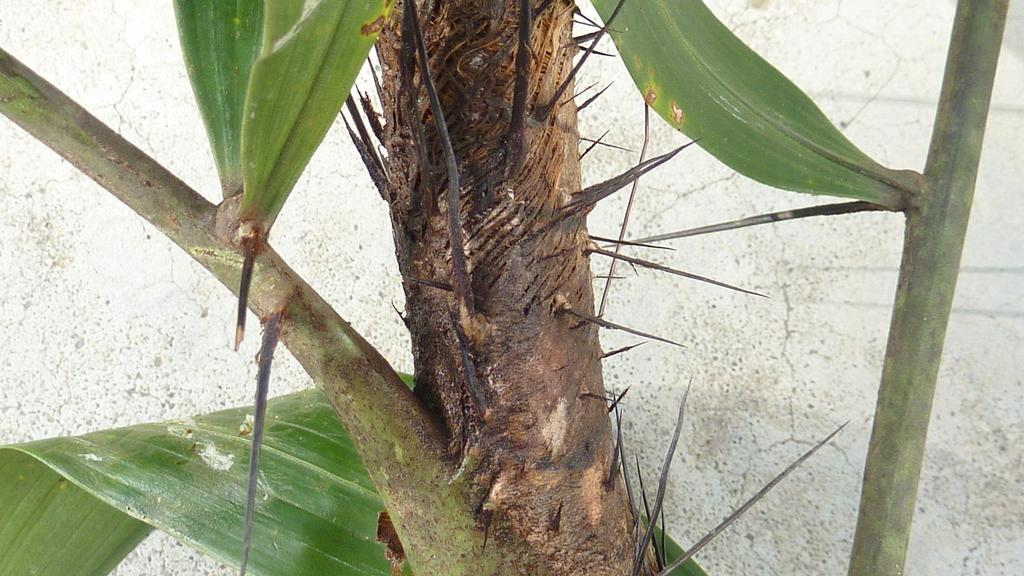What type of object is present in the image? There is a plant in the image. Can you describe the appearance of the plant? The plant has sharp, pointed edges. Does the plant have any other features? Yes, the plant has leaves. How many kittens are playing on the plant in the image? There are no kittens present in the image; it only features a plant with sharp, pointed edges and leaves. Is there any indication of a fight occurring in the image? There is no indication of a fight in the image; it only shows a plant with its features. 